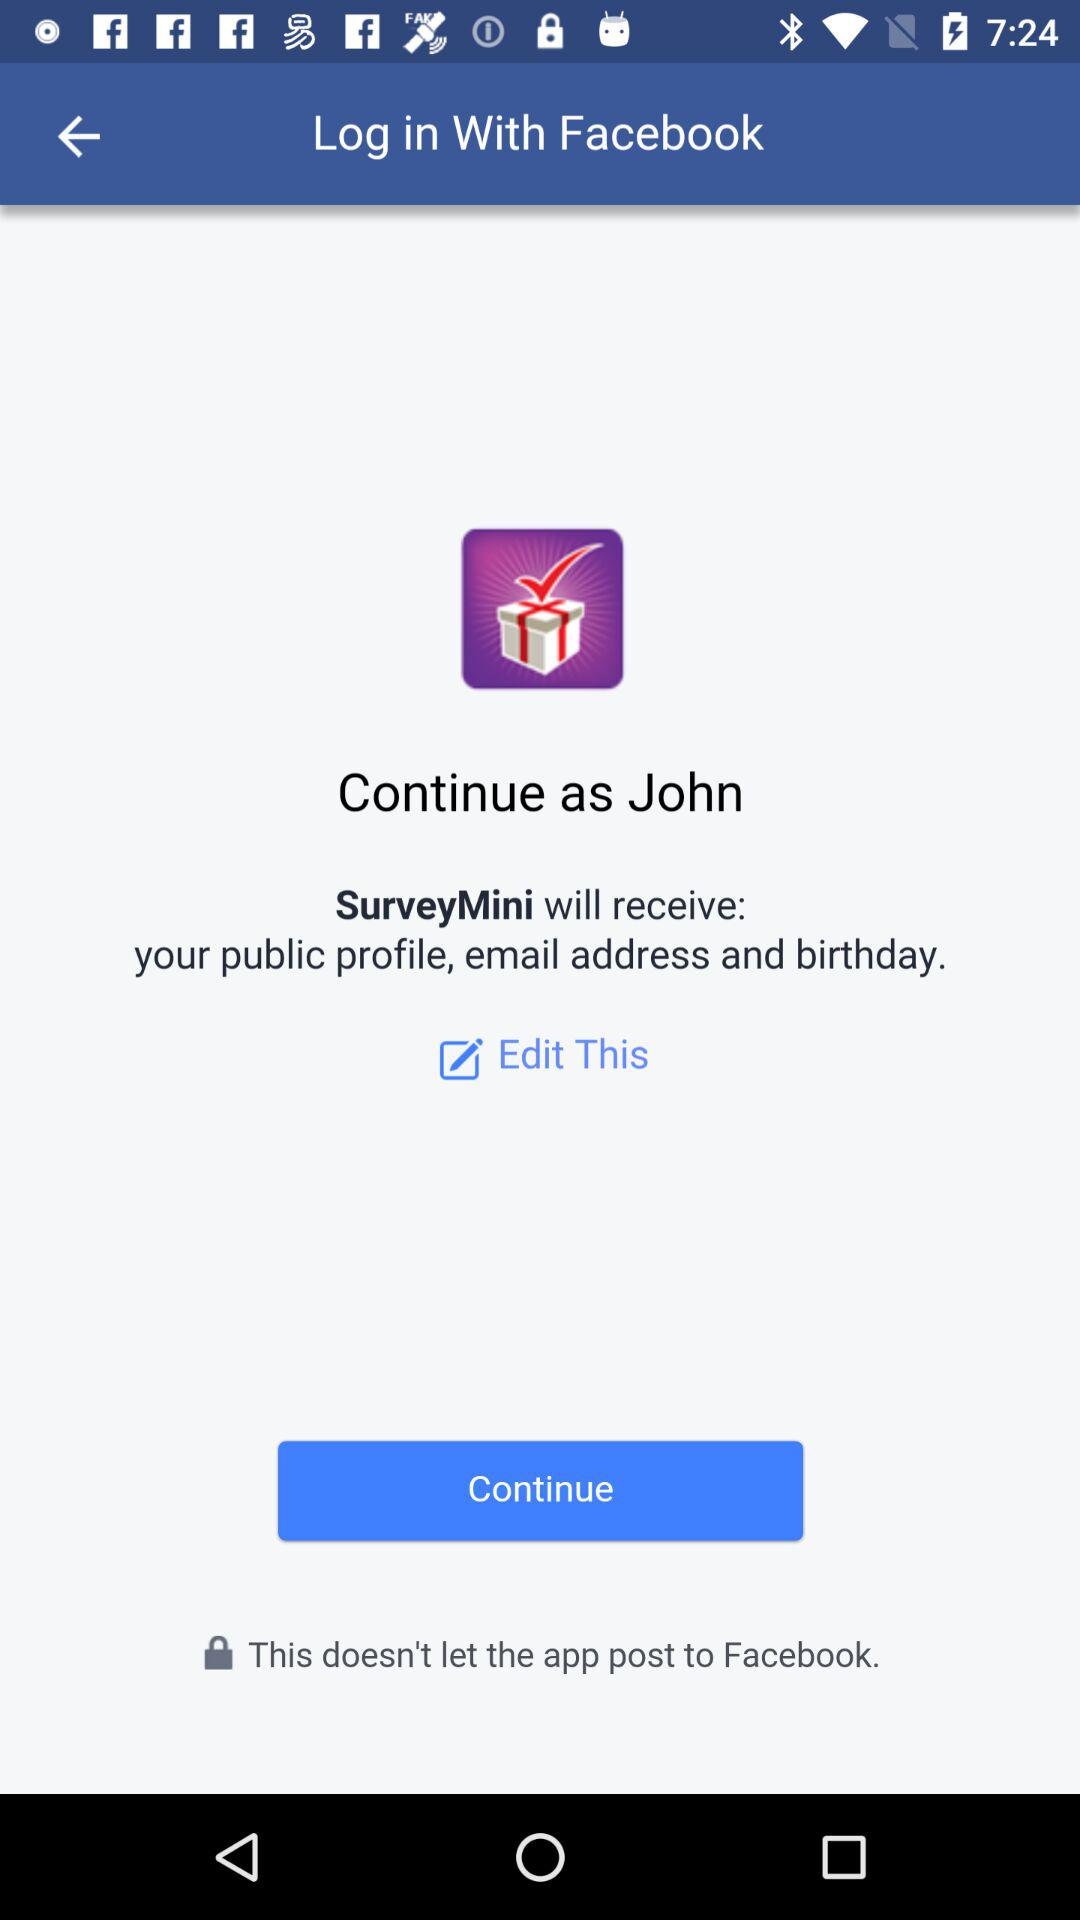What application are we accessing? The application is "SurveyMini". 